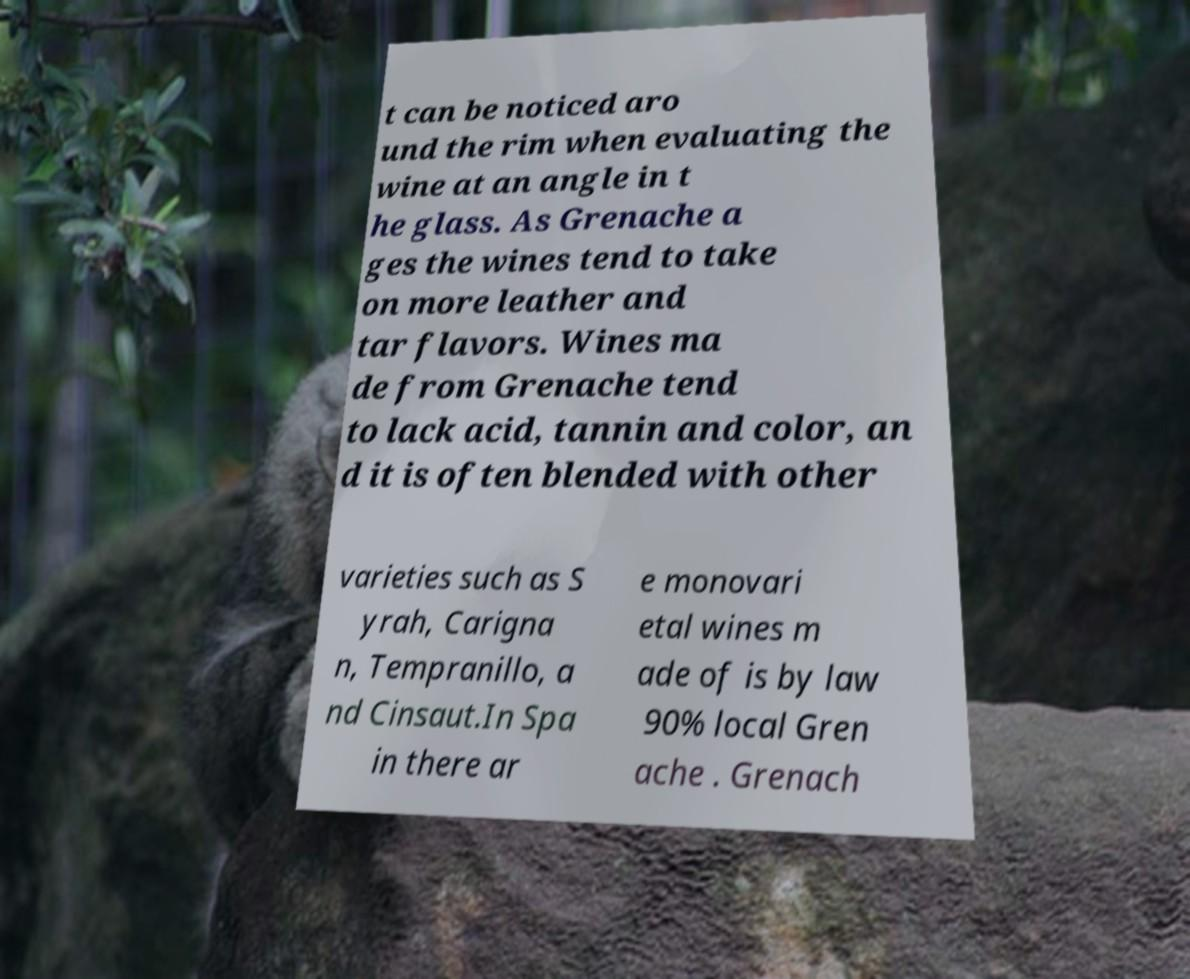Please identify and transcribe the text found in this image. t can be noticed aro und the rim when evaluating the wine at an angle in t he glass. As Grenache a ges the wines tend to take on more leather and tar flavors. Wines ma de from Grenache tend to lack acid, tannin and color, an d it is often blended with other varieties such as S yrah, Carigna n, Tempranillo, a nd Cinsaut.In Spa in there ar e monovari etal wines m ade of is by law 90% local Gren ache . Grenach 